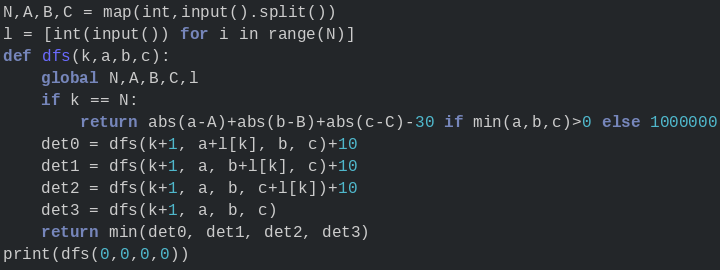Convert code to text. <code><loc_0><loc_0><loc_500><loc_500><_Python_>N,A,B,C = map(int,input().split())
l = [int(input()) for i in range(N)]
def dfs(k,a,b,c):
    global N,A,B,C,l
    if k == N:
        return abs(a-A)+abs(b-B)+abs(c-C)-30 if min(a,b,c)>0 else 1000000
    det0 = dfs(k+1, a+l[k], b, c)+10
    det1 = dfs(k+1, a, b+l[k], c)+10
    det2 = dfs(k+1, a, b, c+l[k])+10
    det3 = dfs(k+1, a, b, c)
    return min(det0, det1, det2, det3)
print(dfs(0,0,0,0))</code> 